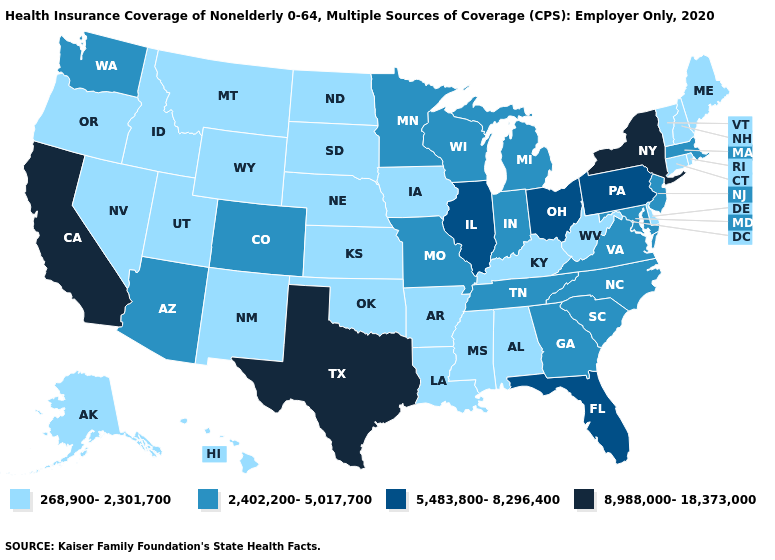Does the map have missing data?
Be succinct. No. What is the lowest value in states that border Florida?
Short answer required. 268,900-2,301,700. Name the states that have a value in the range 268,900-2,301,700?
Quick response, please. Alabama, Alaska, Arkansas, Connecticut, Delaware, Hawaii, Idaho, Iowa, Kansas, Kentucky, Louisiana, Maine, Mississippi, Montana, Nebraska, Nevada, New Hampshire, New Mexico, North Dakota, Oklahoma, Oregon, Rhode Island, South Dakota, Utah, Vermont, West Virginia, Wyoming. What is the lowest value in states that border Idaho?
Short answer required. 268,900-2,301,700. Among the states that border Indiana , which have the highest value?
Give a very brief answer. Illinois, Ohio. Name the states that have a value in the range 8,988,000-18,373,000?
Concise answer only. California, New York, Texas. Name the states that have a value in the range 5,483,800-8,296,400?
Write a very short answer. Florida, Illinois, Ohio, Pennsylvania. What is the highest value in the Northeast ?
Short answer required. 8,988,000-18,373,000. Name the states that have a value in the range 268,900-2,301,700?
Quick response, please. Alabama, Alaska, Arkansas, Connecticut, Delaware, Hawaii, Idaho, Iowa, Kansas, Kentucky, Louisiana, Maine, Mississippi, Montana, Nebraska, Nevada, New Hampshire, New Mexico, North Dakota, Oklahoma, Oregon, Rhode Island, South Dakota, Utah, Vermont, West Virginia, Wyoming. How many symbols are there in the legend?
Concise answer only. 4. Which states hav the highest value in the MidWest?
Write a very short answer. Illinois, Ohio. Among the states that border New York , does Massachusetts have the highest value?
Give a very brief answer. No. What is the lowest value in the USA?
Keep it brief. 268,900-2,301,700. Name the states that have a value in the range 8,988,000-18,373,000?
Keep it brief. California, New York, Texas. Does Minnesota have a lower value than Florida?
Give a very brief answer. Yes. 